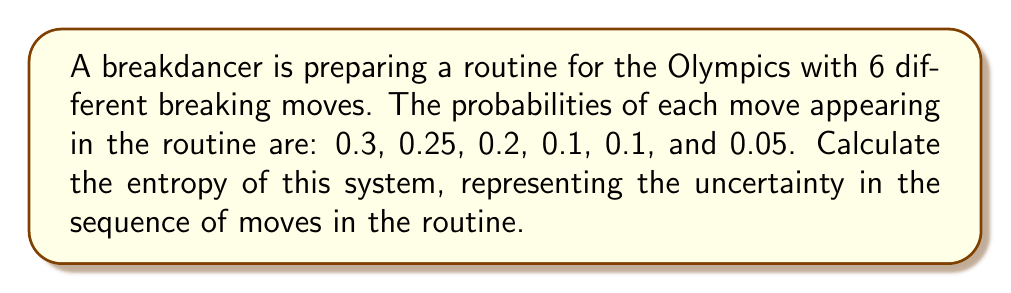Can you solve this math problem? To calculate the entropy of this system, we'll use the Shannon entropy formula:

$$S = -k_B \sum_{i=1}^n p_i \ln p_i$$

Where:
$S$ is the entropy
$k_B$ is Boltzmann's constant (which we'll set to 1 for simplicity)
$p_i$ is the probability of each state (move in this case)
$n$ is the number of possible states (6 in this case)

Let's calculate each term:

1. $-0.3 \ln 0.3 = 0.3611$
2. $-0.25 \ln 0.25 = 0.3466$
3. $-0.2 \ln 0.2 = 0.3219$
4. $-0.1 \ln 0.1 = 0.2303$ (appears twice)
5. $-0.05 \ln 0.05 = 0.1498$

Now, sum all these terms:

$$S = 0.3611 + 0.3466 + 0.3219 + 0.2303 + 0.2303 + 0.1498 = 1.6400$$

Therefore, the entropy of the system is approximately 1.6400.
Answer: 1.6400 